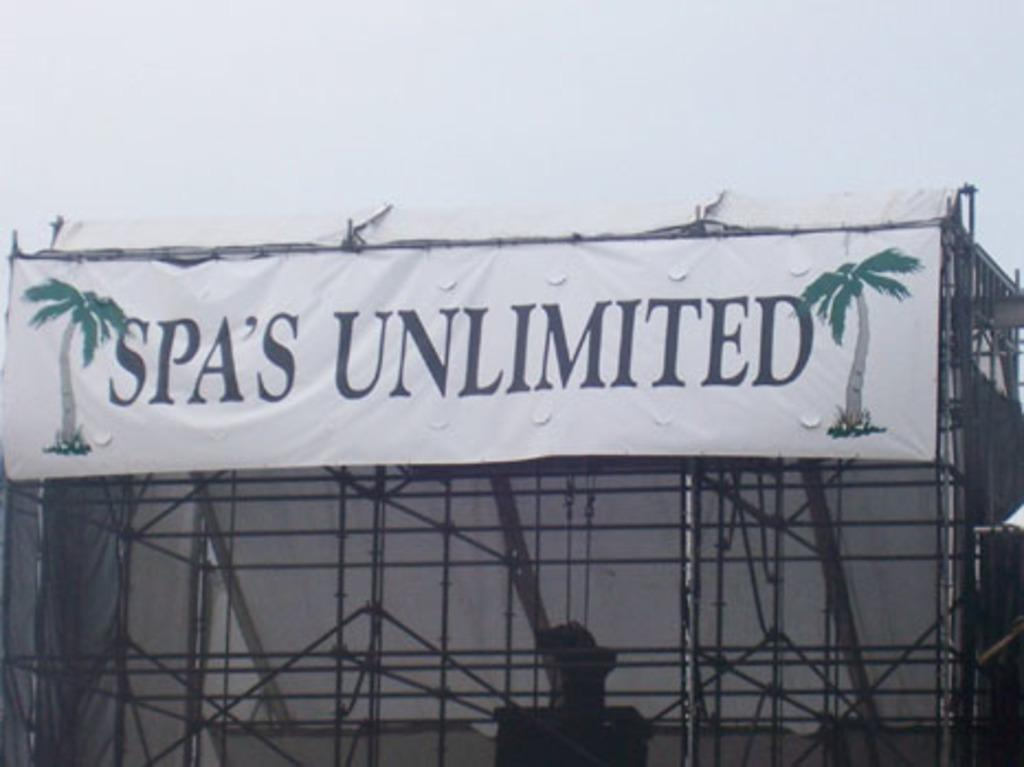<image>
Present a compact description of the photo's key features. A banner for Spa's Unlimited has two palm trees on it and hangs from some scaffolding. 